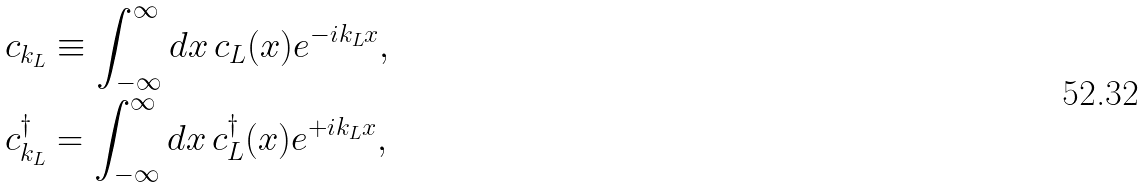Convert formula to latex. <formula><loc_0><loc_0><loc_500><loc_500>c _ { k _ { L } } & \equiv \int _ { - \infty } ^ { \infty } d x \, c _ { L } ( x ) e ^ { - i k _ { L } x } , \\ c _ { k _ { L } } ^ { \dagger } & = \int _ { - \infty } ^ { \infty } d x \, c _ { L } ^ { \dagger } ( x ) e ^ { + i k _ { L } x } ,</formula> 